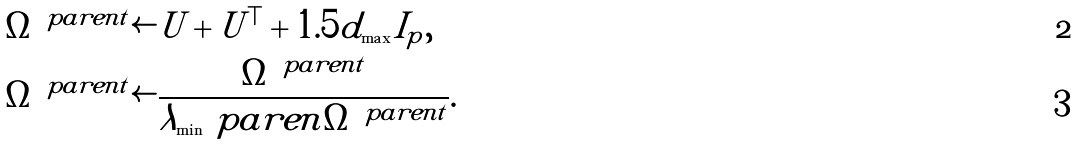Convert formula to latex. <formula><loc_0><loc_0><loc_500><loc_500>& \Omega ^ { \ p a r e n { t } } \leftarrow U + U ^ { \top } + 1 . 5 d _ { \max } I _ { p } , \\ & \Omega ^ { \ p a r e n { t } } \leftarrow \frac { \Omega ^ { \ p a r e n { t } } } { \lambda _ { \min } \ p a r e n { \Omega ^ { \ p a r e n { t } } } } .</formula> 